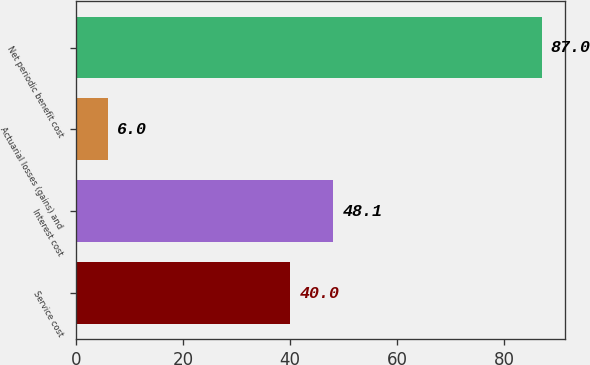Convert chart. <chart><loc_0><loc_0><loc_500><loc_500><bar_chart><fcel>Service cost<fcel>Interest cost<fcel>Actuarial losses (gains) and<fcel>Net periodic benefit cost<nl><fcel>40<fcel>48.1<fcel>6<fcel>87<nl></chart> 